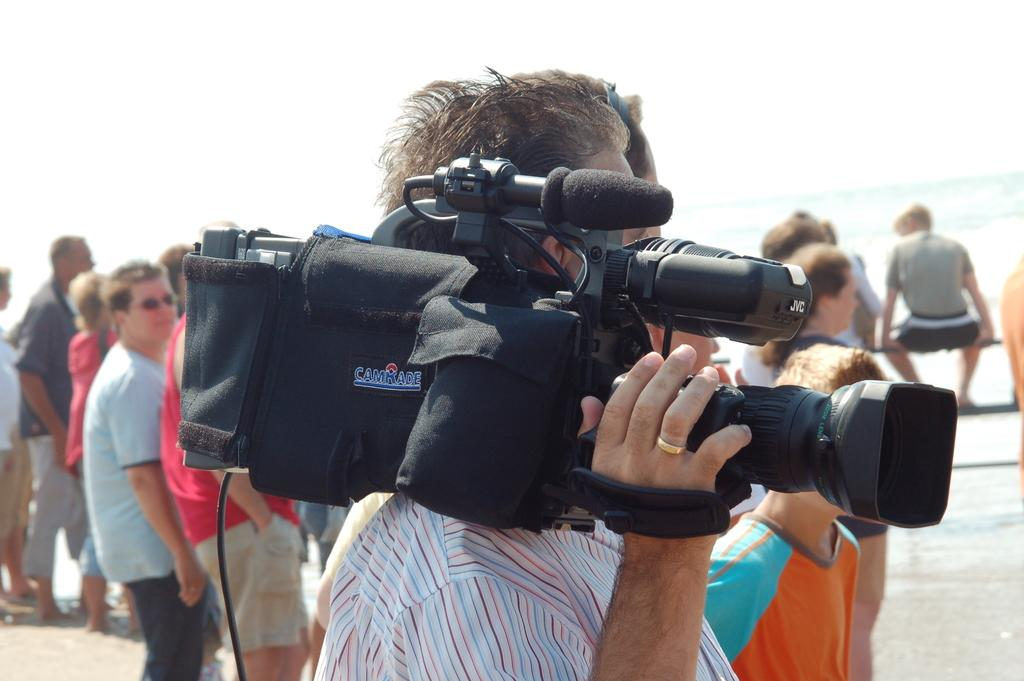What can be seen in the background of the image? The sky is visible in the background of the image. Who or what is present in the image? There are people in the image. Can you describe the man in the image? A man is standing in the image and holding a camera. What type of pencil is the man using to draw in the image? There is no pencil present in the image; the man is holding a camera. What kind of apparel is the woman wearing in the image? There is no woman present in the image; only a man holding a camera is mentioned. 